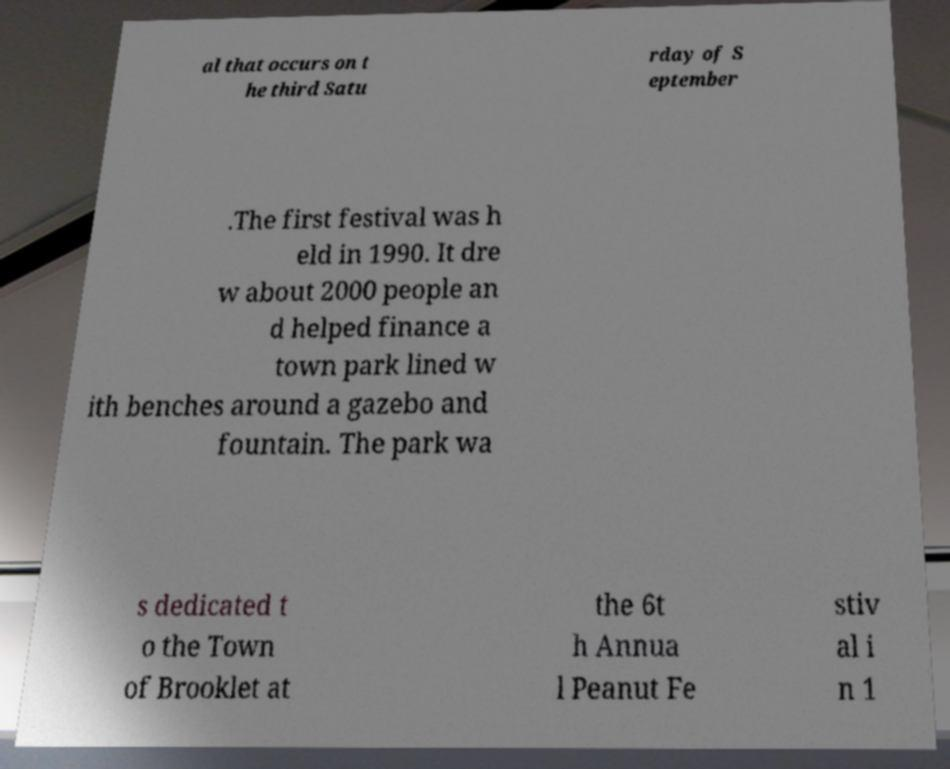Can you read and provide the text displayed in the image?This photo seems to have some interesting text. Can you extract and type it out for me? al that occurs on t he third Satu rday of S eptember .The first festival was h eld in 1990. It dre w about 2000 people an d helped finance a town park lined w ith benches around a gazebo and fountain. The park wa s dedicated t o the Town of Brooklet at the 6t h Annua l Peanut Fe stiv al i n 1 